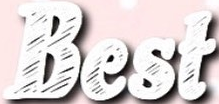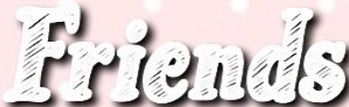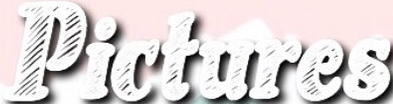Read the text content from these images in order, separated by a semicolon. Best; Friends; Pictures 